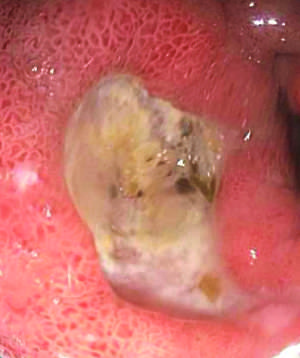s the high-power detail of an asbestos body associated with nsaid use?
Answer the question using a single word or phrase. No 